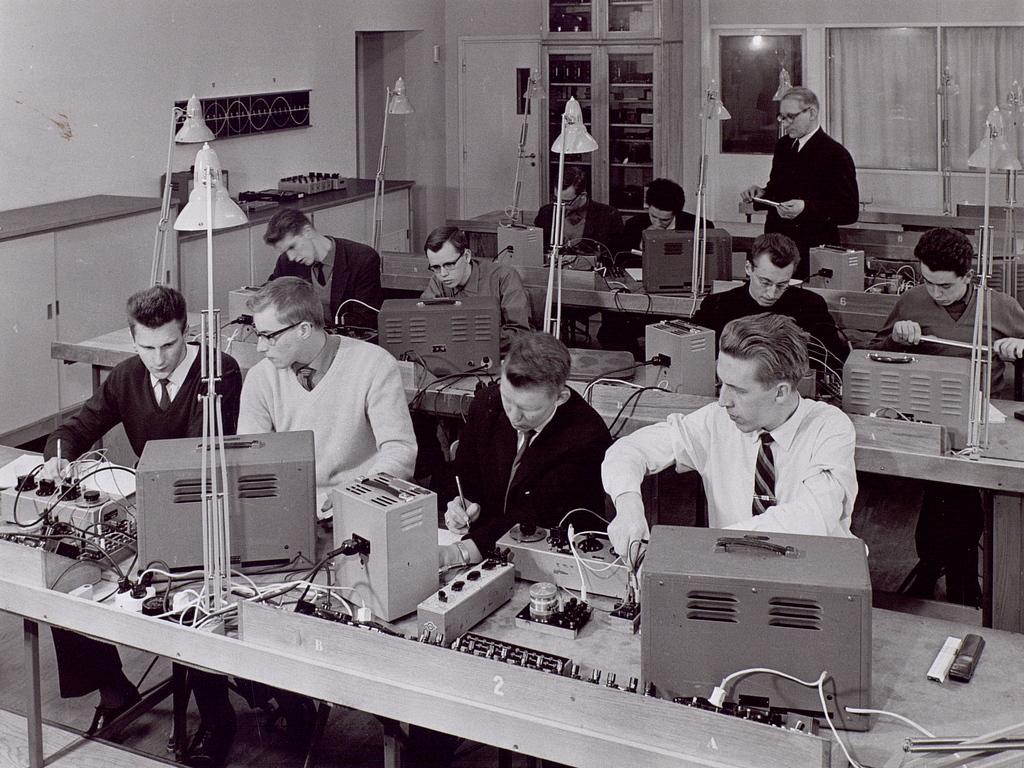Please provide a concise description of this image. In this image I can see the black and white picture in which I can see few persons are sitting in front of the desks. On the desks I can see few lights, few electric equipment, few wires and few other objects. In the background I can see a person standing, few windows, the wall, few lights, the door and few other objects. 